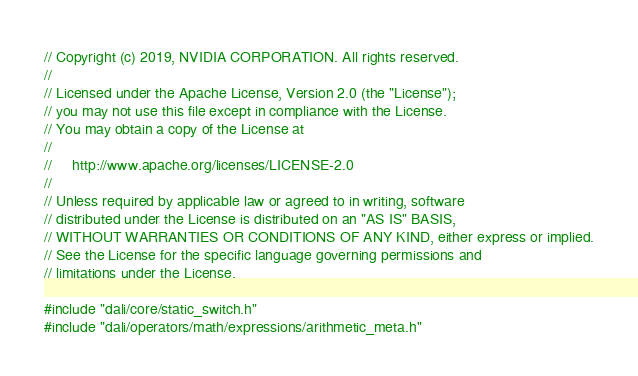<code> <loc_0><loc_0><loc_500><loc_500><_Cuda_>
// Copyright (c) 2019, NVIDIA CORPORATION. All rights reserved.
//
// Licensed under the Apache License, Version 2.0 (the "License");
// you may not use this file except in compliance with the License.
// You may obtain a copy of the License at
//
//     http://www.apache.org/licenses/LICENSE-2.0
//
// Unless required by applicable law or agreed to in writing, software
// distributed under the License is distributed on an "AS IS" BASIS,
// WITHOUT WARRANTIES OR CONDITIONS OF ANY KIND, either express or implied.
// See the License for the specific language governing permissions and
// limitations under the License.

#include "dali/core/static_switch.h"
#include "dali/operators/math/expressions/arithmetic_meta.h"</code> 